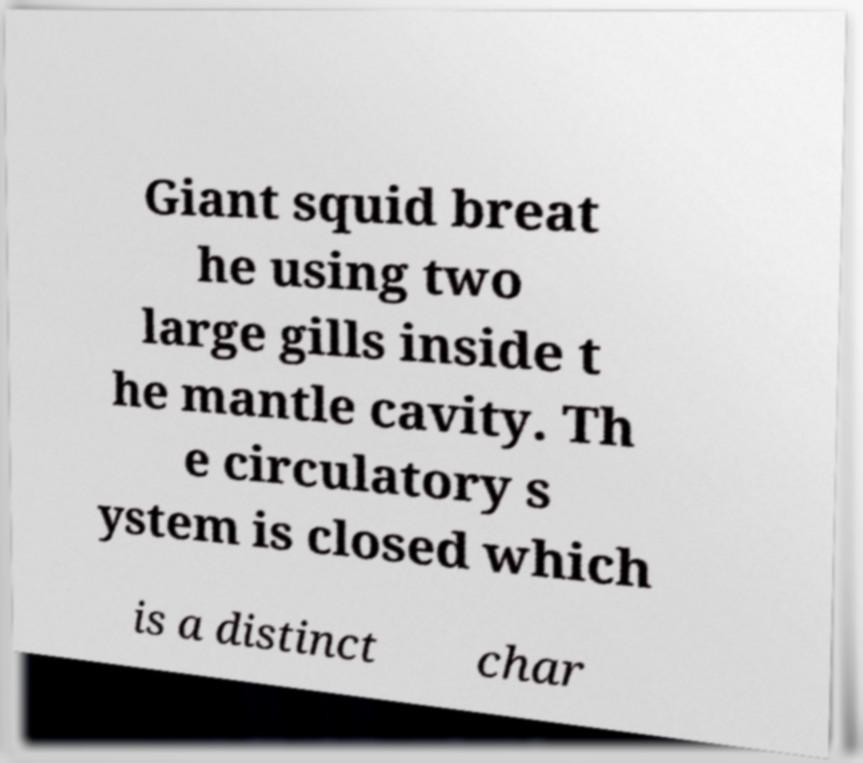Can you accurately transcribe the text from the provided image for me? Giant squid breat he using two large gills inside t he mantle cavity. Th e circulatory s ystem is closed which is a distinct char 